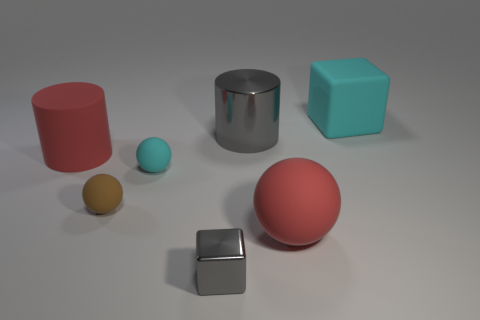How might the lighting in the scene affect the mood or atmosphere depicted in the image? The soft and even lighting creates a calm and neutral mood, free from any dramatic shadows or highlights. It allows for clear observation of each object's true color and texture, presenting an atmosphere of serenity or objectivity. 